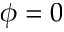<formula> <loc_0><loc_0><loc_500><loc_500>\phi = 0</formula> 